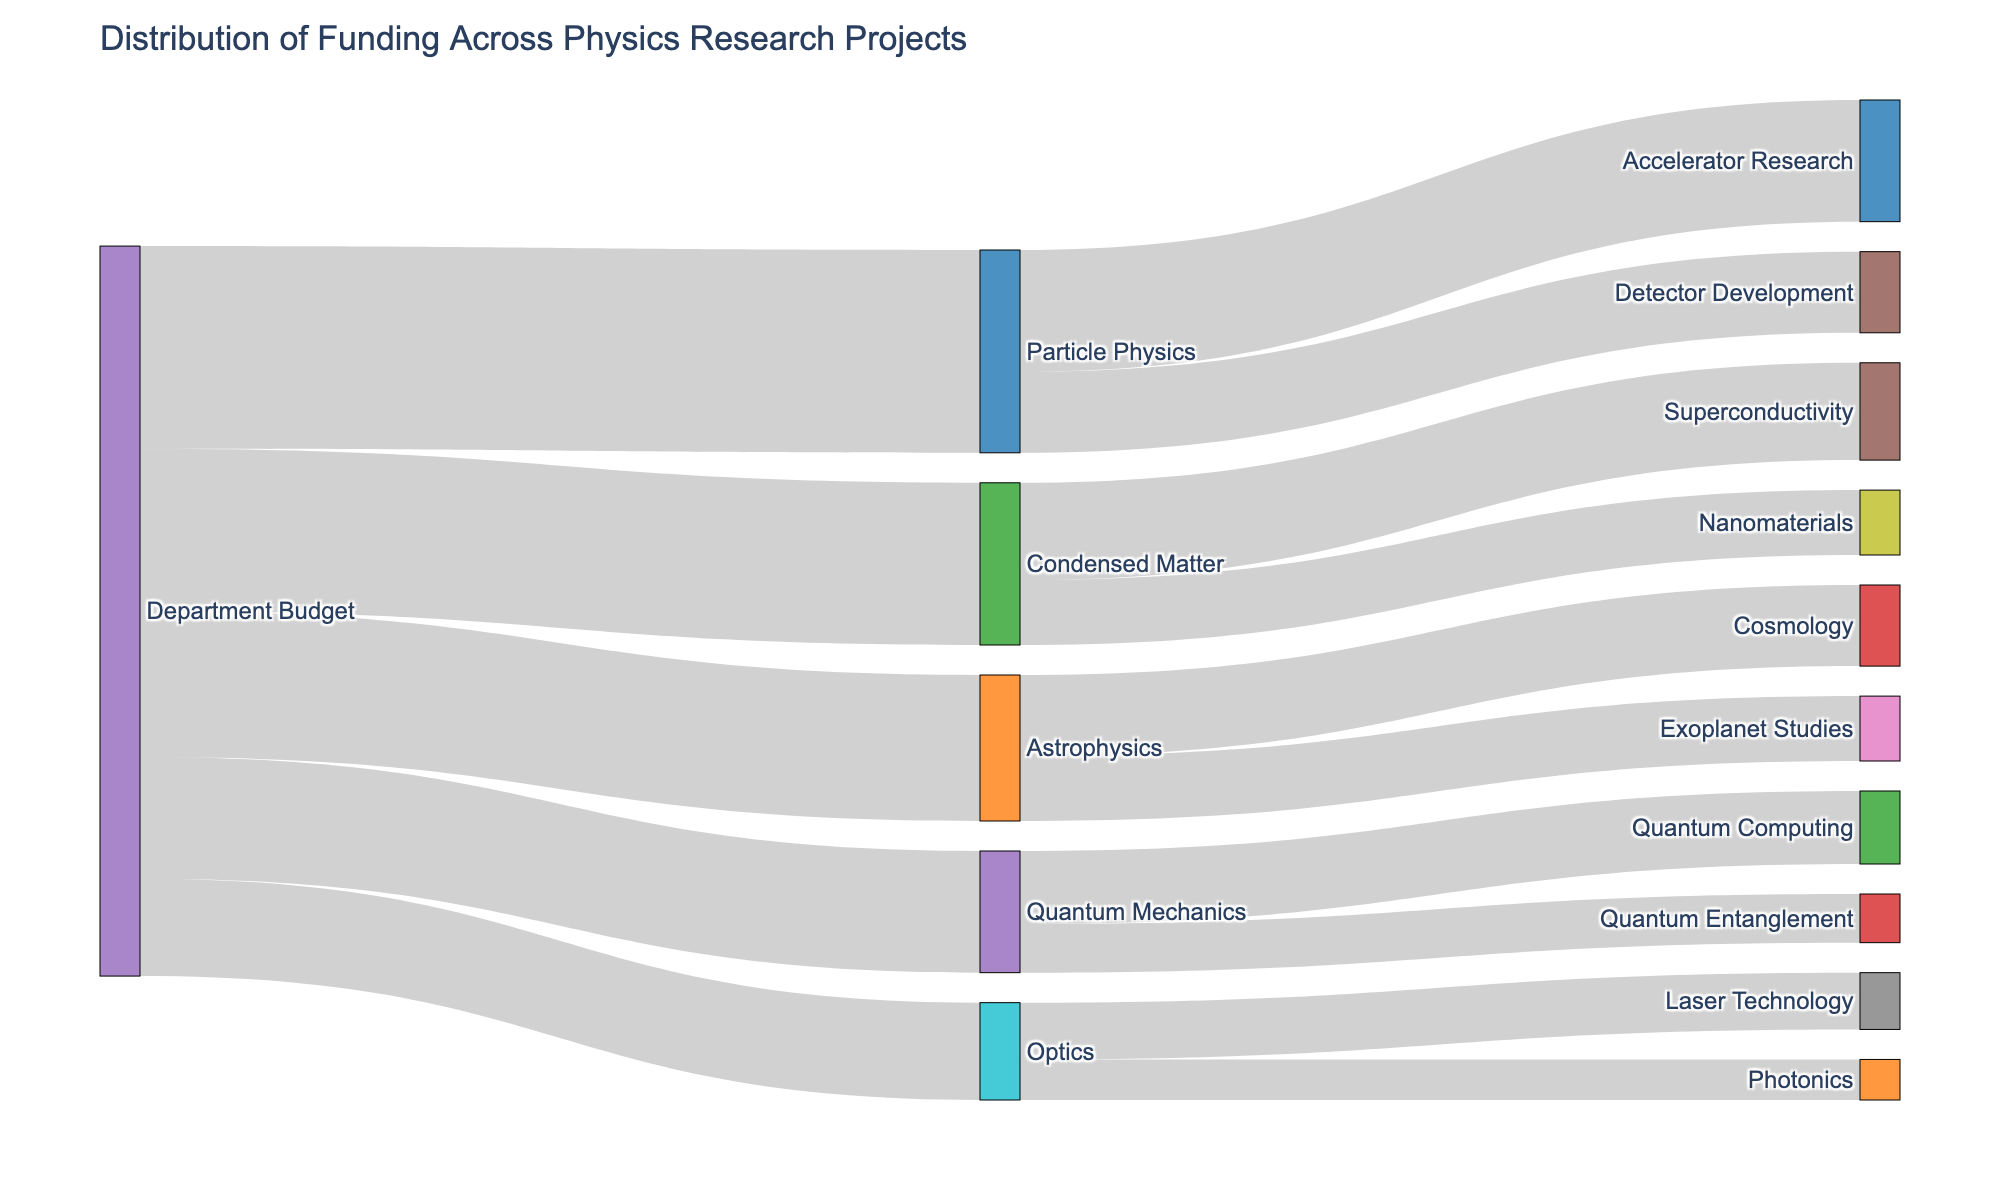Which research area receives the highest funding from the department budget? The figure shows arrows from the "Department Budget" node to different research areas. The width of the arrows indicates the funding amount. The arrow to "Particle Physics" is the widest.
Answer: Particle Physics Which research area within "Quantum Mechanics" has more funding? The figure shows two arrows from "Quantum Mechanics" to its sub-areas, "Quantum Computing" and "Quantum Entanglement". The arrow to "Quantum Computing" is wider.
Answer: Quantum Computing How much funding is allocated to "Exoplanet Studies" in the Astrophysics category? There is an arrow from "Astrophysics" to "Exoplanet Studies". Following the arrow shows it is labeled with a funding amount of 80,000.
Answer: 80,000 What is the total funding allocated to "Particle Physics" and "Condensed Matter"? The figure shows arrows from the "Department Budget" to "Particle Physics" and "Condensed Matter". Adding the values from both arrows: 250,000 (Particle Physics) + 200,000 (Condensed Matter).
Answer: 450,000 Which sub-area of "Optics" receives the least funding? Under "Optics", there are arrows leading to "Laser Technology" and "Photonics". The arrow to "Photonics" is narrower.
Answer: Photonics Compare the funding between "Astrophysics" and "Quantum Mechanics". Which one is higher and by how much? The figure shows arrows from "Department Budget" to these two areas. Astrophysics gets 180,000, Quantum Mechanics gets 150,000. The difference is 180,000 - 150,000.
Answer: Astrophysics, 30,000 more What proportion of the "Department Budget" is allocated to "Optics"? The total department budget is the sum of all allocations: 250,000 + 180,000 + 200,000 + 150,000 + 120,000 = 900,000. The funding for Optics is 120,000. The proportion is calculated as (120,000 / 900,000) * 100%.
Answer: 13.33% Which sub-category under "Condensed Matter" has the largest funding allocation? There are two arrows from "Condensed Matter" to "Superconductivity" and "Nanomaterials". The arrow to "Superconductivity" is wider.
Answer: Superconductivity How much total funding is allocated to "Quantum Mechanics" projects? The figure shows one arrow from "Department Budget" to "Quantum Mechanics" with 150,000 and then distributes into "Quantum Computing" and "Quantum Entanglement". Adding those values confirms the total.
Answer: 150,000 Determine the least funded sub-area across all research categories and state its value. Observing the narrowest arrows among all sub-categories, "Photonics" under "Optics" has the least funding of 50,000.
Answer: Photonics, 50,000 